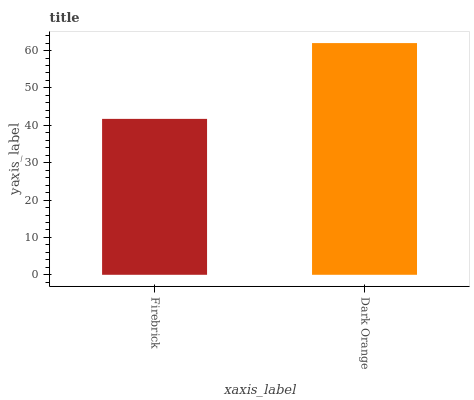Is Firebrick the minimum?
Answer yes or no. Yes. Is Dark Orange the maximum?
Answer yes or no. Yes. Is Dark Orange the minimum?
Answer yes or no. No. Is Dark Orange greater than Firebrick?
Answer yes or no. Yes. Is Firebrick less than Dark Orange?
Answer yes or no. Yes. Is Firebrick greater than Dark Orange?
Answer yes or no. No. Is Dark Orange less than Firebrick?
Answer yes or no. No. Is Dark Orange the high median?
Answer yes or no. Yes. Is Firebrick the low median?
Answer yes or no. Yes. Is Firebrick the high median?
Answer yes or no. No. Is Dark Orange the low median?
Answer yes or no. No. 